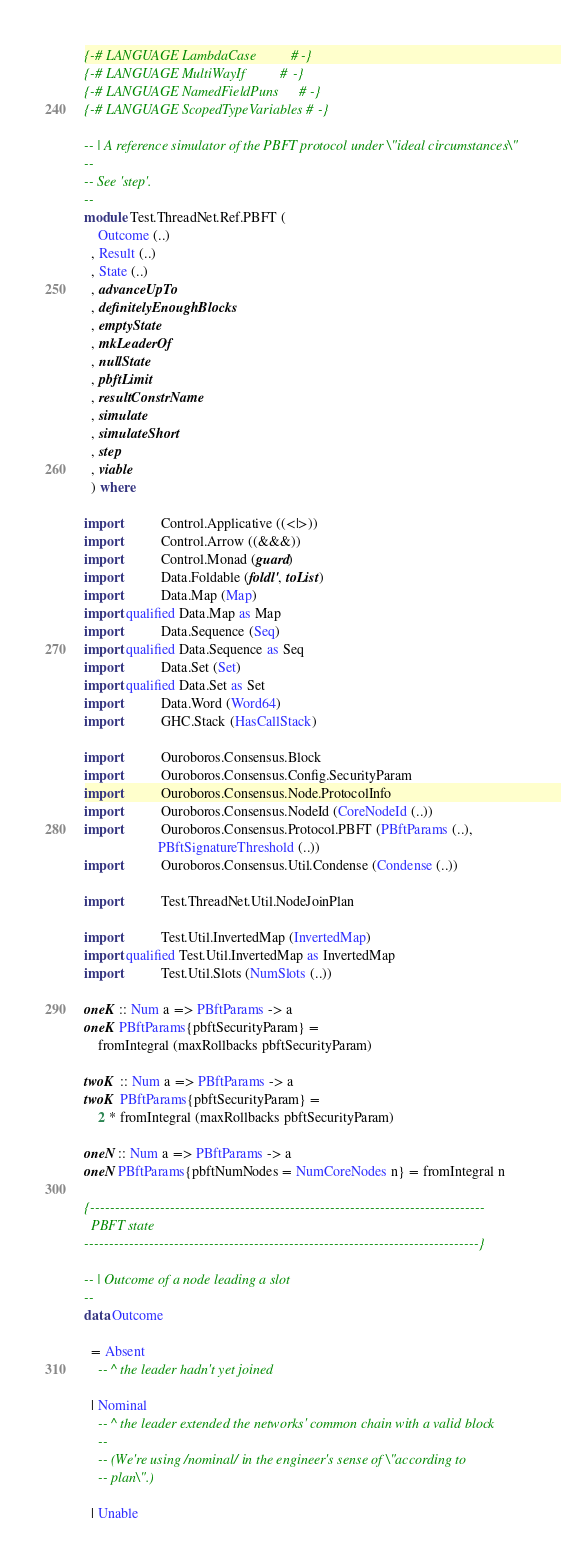Convert code to text. <code><loc_0><loc_0><loc_500><loc_500><_Haskell_>{-# LANGUAGE LambdaCase          #-}
{-# LANGUAGE MultiWayIf          #-}
{-# LANGUAGE NamedFieldPuns      #-}
{-# LANGUAGE ScopedTypeVariables #-}

-- | A reference simulator of the PBFT protocol under \"ideal circumstances\"
--
-- See 'step'.
--
module Test.ThreadNet.Ref.PBFT (
    Outcome (..)
  , Result (..)
  , State (..)
  , advanceUpTo
  , definitelyEnoughBlocks
  , emptyState
  , mkLeaderOf
  , nullState
  , pbftLimit
  , resultConstrName
  , simulate
  , simulateShort
  , step
  , viable
  ) where

import           Control.Applicative ((<|>))
import           Control.Arrow ((&&&))
import           Control.Monad (guard)
import           Data.Foldable (foldl', toList)
import           Data.Map (Map)
import qualified Data.Map as Map
import           Data.Sequence (Seq)
import qualified Data.Sequence as Seq
import           Data.Set (Set)
import qualified Data.Set as Set
import           Data.Word (Word64)
import           GHC.Stack (HasCallStack)

import           Ouroboros.Consensus.Block
import           Ouroboros.Consensus.Config.SecurityParam
import           Ouroboros.Consensus.Node.ProtocolInfo
import           Ouroboros.Consensus.NodeId (CoreNodeId (..))
import           Ouroboros.Consensus.Protocol.PBFT (PBftParams (..),
                     PBftSignatureThreshold (..))
import           Ouroboros.Consensus.Util.Condense (Condense (..))

import           Test.ThreadNet.Util.NodeJoinPlan

import           Test.Util.InvertedMap (InvertedMap)
import qualified Test.Util.InvertedMap as InvertedMap
import           Test.Util.Slots (NumSlots (..))

oneK :: Num a => PBftParams -> a
oneK PBftParams{pbftSecurityParam} =
    fromIntegral (maxRollbacks pbftSecurityParam)

twoK :: Num a => PBftParams -> a
twoK PBftParams{pbftSecurityParam} =
    2 * fromIntegral (maxRollbacks pbftSecurityParam)

oneN :: Num a => PBftParams -> a
oneN PBftParams{pbftNumNodes = NumCoreNodes n} = fromIntegral n

{-------------------------------------------------------------------------------
  PBFT state
-------------------------------------------------------------------------------}

-- | Outcome of a node leading a slot
--
data Outcome

  = Absent
    -- ^ the leader hadn't yet joined

  | Nominal
    -- ^ the leader extended the networks' common chain with a valid block
    --
    -- (We're using /nominal/ in the engineer's sense of \"according to
    -- plan\".)

  | Unable</code> 